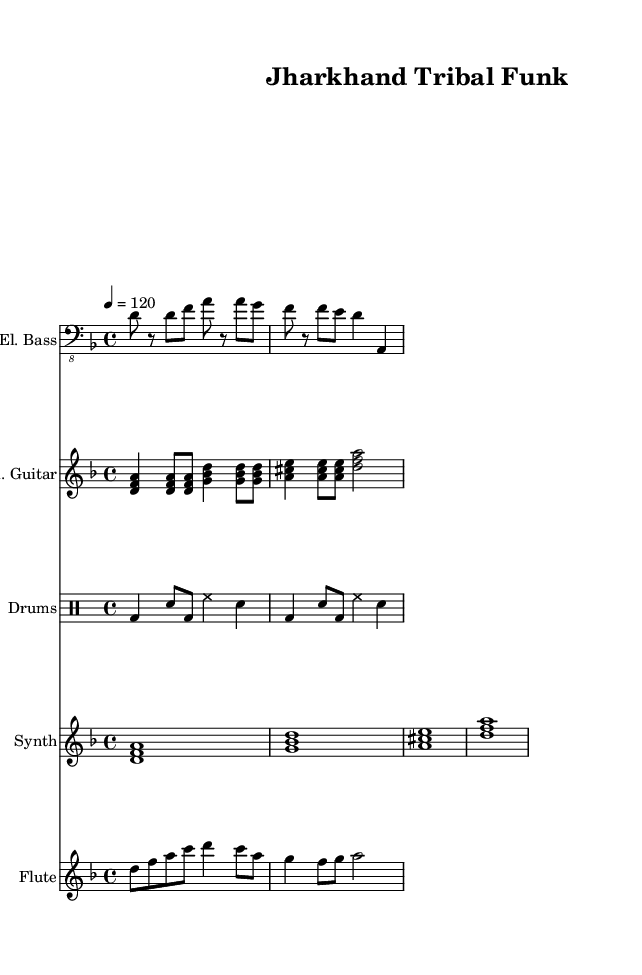What is the key signature of this music? The key signature contains one flat, which indicates the music is in D minor. In the key signature section of the sheet music, we can see the relevant symbol indicating this, specifically one flat.
Answer: D minor What is the time signature of this piece? The time signature is found at the beginning of the music. In this case, it shows a '4/4' time signature, indicating four beats in each measure with each quarter note receiving one beat.
Answer: 4/4 What is the tempo marking of this piece? The tempo marking is indicated as '4 = 120.' This indicates the piece should be played at a pace of 120 beats per minute, with each beat represented by the quarter note.
Answer: 120 Which instruments are included in this score? The instruments are listed at the start of each staff. They include Electric Bass, Electric Guitar, Drums, Synthesizer, and Flute. By observing the instrument names on the left side of the respective staves, we can identify them clearly.
Answer: Electric Bass, Electric Guitar, Drums, Synthesizer, Flute What type of musical scale is used predominantly in this funky piece? The piece utilizes minor scales, as indicated by the key signature of D minor and the overall harmonic structure that emphasizes the notes of this scale, particularly within the Electric Guitar and Bass lines, which play notes from the D minor scale.
Answer: Minor scale Describe the function of the electric bass in this score. The electric bass serves as the harmonic foundation of the piece, providing rhythmic stability and depth. This can be observed from the bass staff where the notes played directly interact with the drum pattern creating a groove typical of funk music.
Answer: Rhythmic foundation What rhythmic elements stand out in the drum pattern? The drum pattern features a combination of bass drum, snare drum, and hi-hat, producing a syncopated rhythmic feel typical of funk music. The alternating patterns and accents create an energetic groove, which can be seen visually through the different note symbols on the drum staff.
Answer: Syncopated groove 